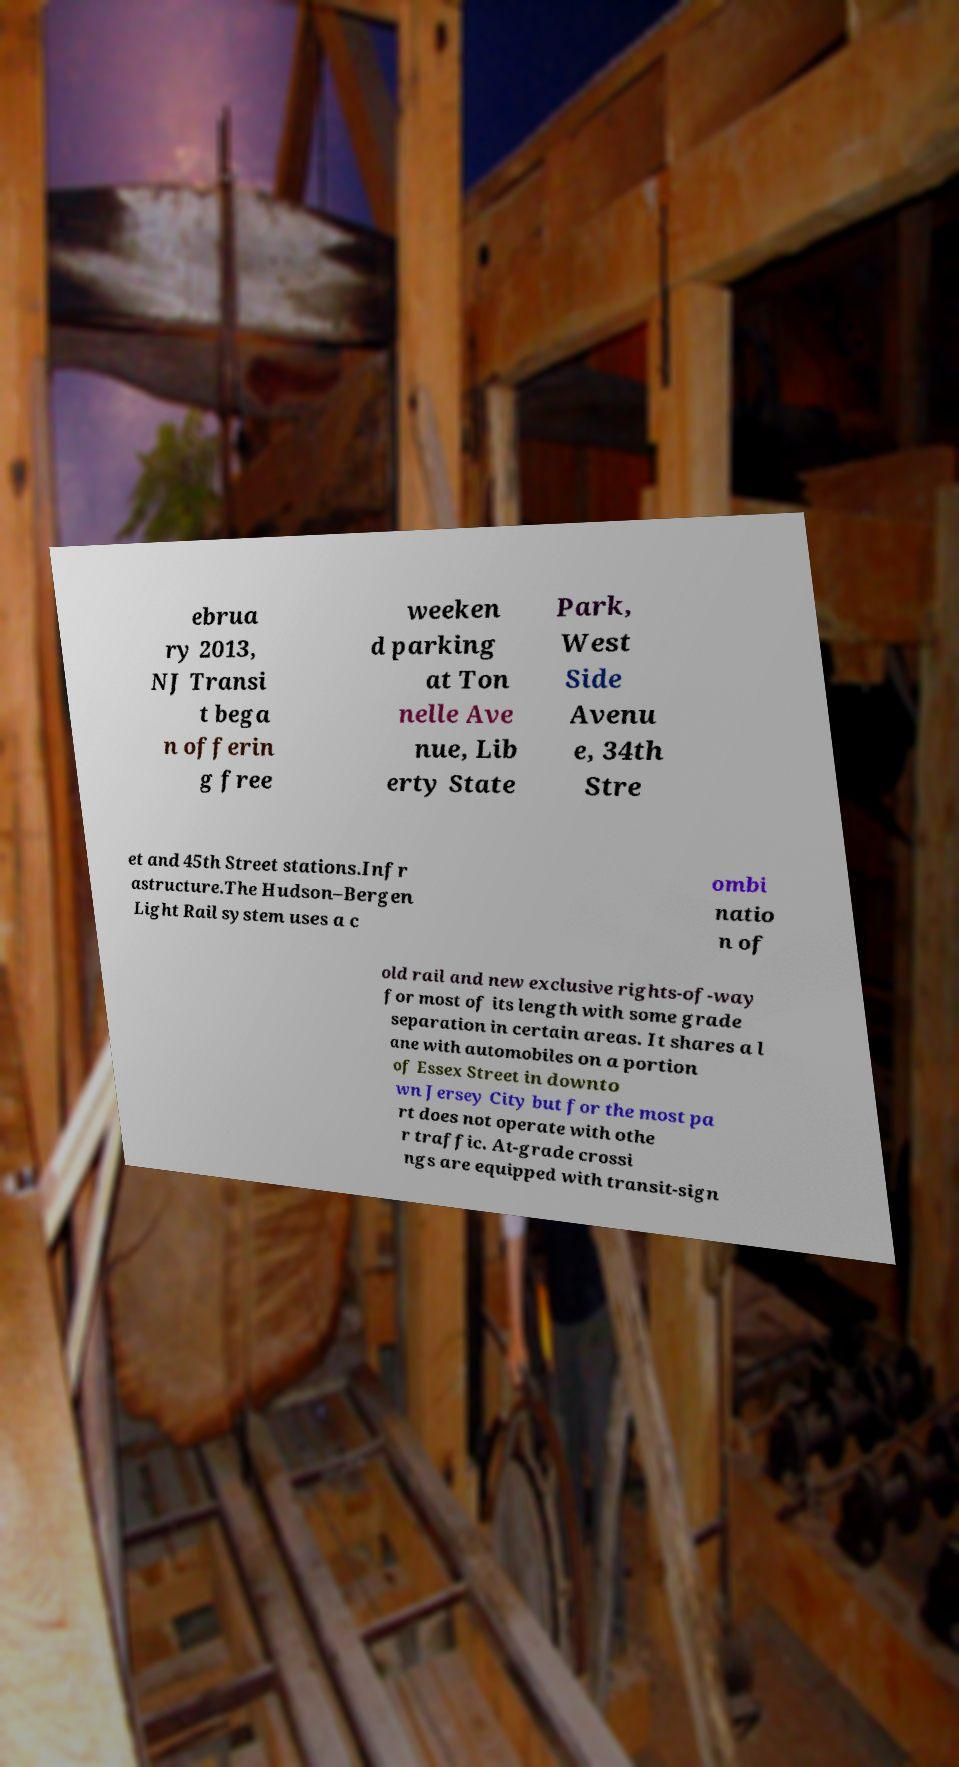Can you accurately transcribe the text from the provided image for me? ebrua ry 2013, NJ Transi t bega n offerin g free weeken d parking at Ton nelle Ave nue, Lib erty State Park, West Side Avenu e, 34th Stre et and 45th Street stations.Infr astructure.The Hudson–Bergen Light Rail system uses a c ombi natio n of old rail and new exclusive rights-of-way for most of its length with some grade separation in certain areas. It shares a l ane with automobiles on a portion of Essex Street in downto wn Jersey City but for the most pa rt does not operate with othe r traffic. At-grade crossi ngs are equipped with transit-sign 